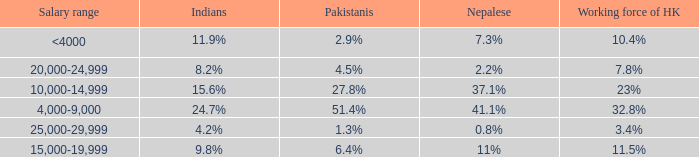If the salary range is 4,000-9,000, what is the Indians %? 24.7%. 